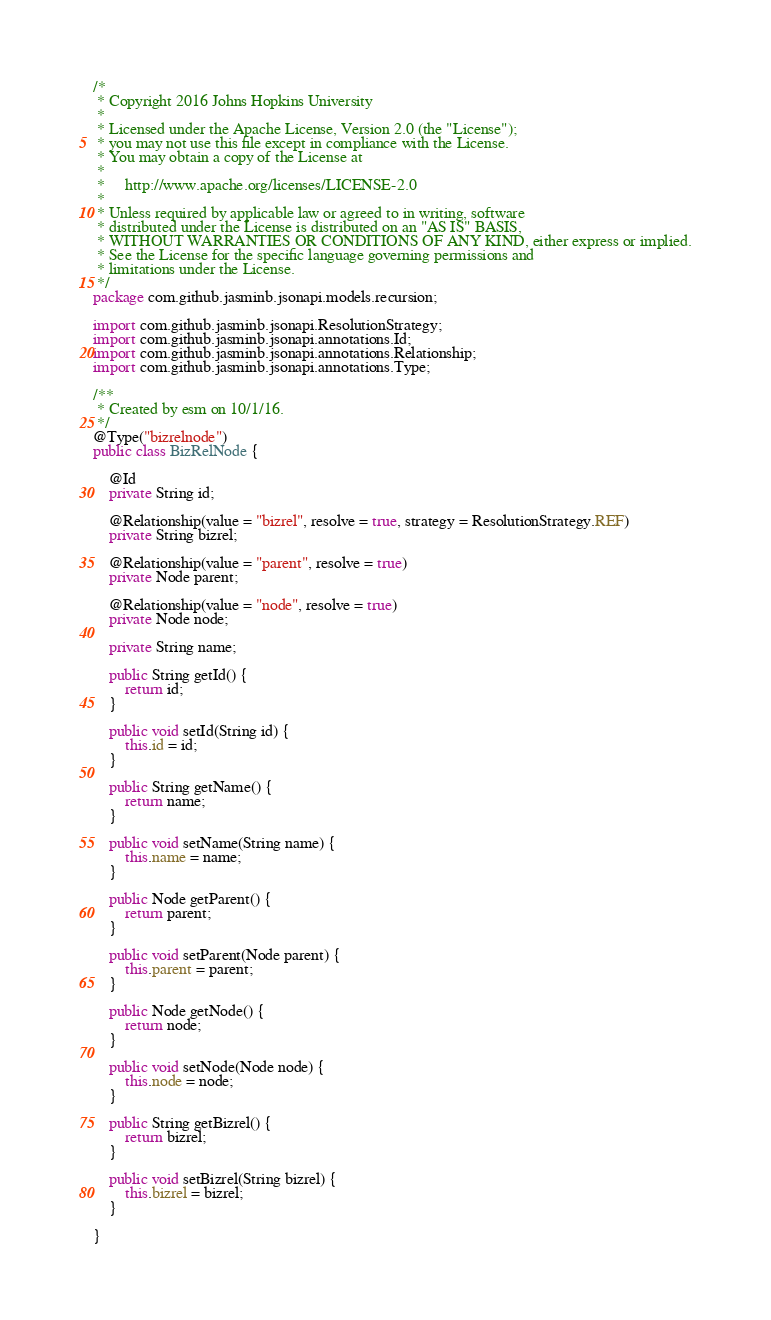<code> <loc_0><loc_0><loc_500><loc_500><_Java_>/*
 * Copyright 2016 Johns Hopkins University
 *
 * Licensed under the Apache License, Version 2.0 (the "License");
 * you may not use this file except in compliance with the License.
 * You may obtain a copy of the License at
 *
 *     http://www.apache.org/licenses/LICENSE-2.0
 *
 * Unless required by applicable law or agreed to in writing, software
 * distributed under the License is distributed on an "AS IS" BASIS,
 * WITHOUT WARRANTIES OR CONDITIONS OF ANY KIND, either express or implied.
 * See the License for the specific language governing permissions and
 * limitations under the License.
 */
package com.github.jasminb.jsonapi.models.recursion;

import com.github.jasminb.jsonapi.ResolutionStrategy;
import com.github.jasminb.jsonapi.annotations.Id;
import com.github.jasminb.jsonapi.annotations.Relationship;
import com.github.jasminb.jsonapi.annotations.Type;

/**
 * Created by esm on 10/1/16.
 */
@Type("bizrelnode")
public class BizRelNode {

    @Id
    private String id;

    @Relationship(value = "bizrel", resolve = true, strategy = ResolutionStrategy.REF)
    private String bizrel;

    @Relationship(value = "parent", resolve = true)
    private Node parent;

    @Relationship(value = "node", resolve = true)
    private Node node;

    private String name;

    public String getId() {
        return id;
    }

    public void setId(String id) {
        this.id = id;
    }

    public String getName() {
        return name;
    }

    public void setName(String name) {
        this.name = name;
    }

    public Node getParent() {
        return parent;
    }

    public void setParent(Node parent) {
        this.parent = parent;
    }

    public Node getNode() {
        return node;
    }

    public void setNode(Node node) {
        this.node = node;
    }

    public String getBizrel() {
        return bizrel;
    }

    public void setBizrel(String bizrel) {
        this.bizrel = bizrel;
    }

}
</code> 